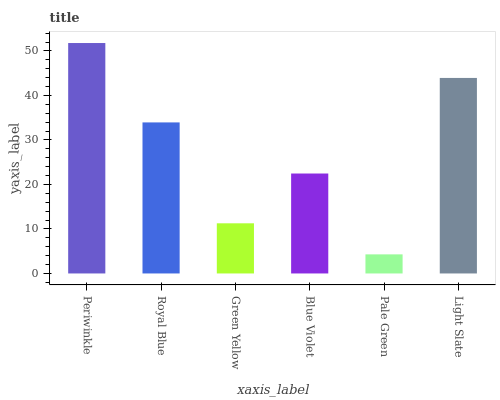Is Royal Blue the minimum?
Answer yes or no. No. Is Royal Blue the maximum?
Answer yes or no. No. Is Periwinkle greater than Royal Blue?
Answer yes or no. Yes. Is Royal Blue less than Periwinkle?
Answer yes or no. Yes. Is Royal Blue greater than Periwinkle?
Answer yes or no. No. Is Periwinkle less than Royal Blue?
Answer yes or no. No. Is Royal Blue the high median?
Answer yes or no. Yes. Is Blue Violet the low median?
Answer yes or no. Yes. Is Pale Green the high median?
Answer yes or no. No. Is Light Slate the low median?
Answer yes or no. No. 